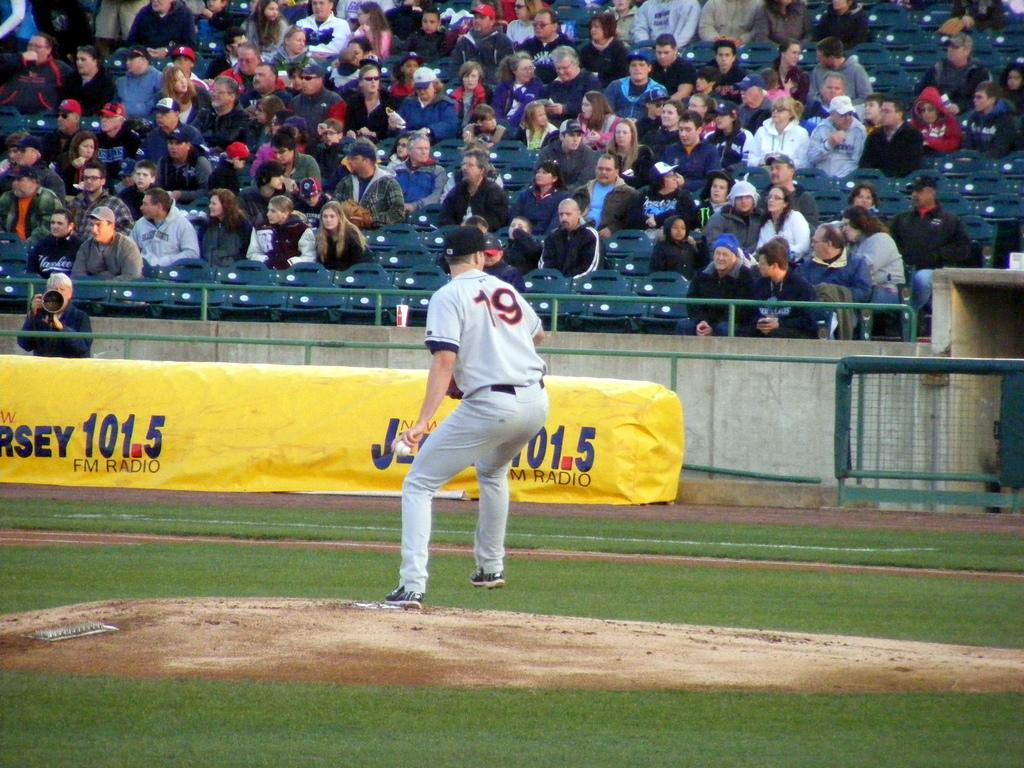<image>
Provide a brief description of the given image. Player number 19 stands in front of an ad for radio station 101.5. 